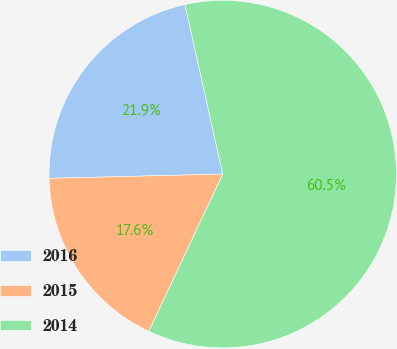Convert chart to OTSL. <chart><loc_0><loc_0><loc_500><loc_500><pie_chart><fcel>2016<fcel>2015<fcel>2014<nl><fcel>21.9%<fcel>17.62%<fcel>60.48%<nl></chart> 